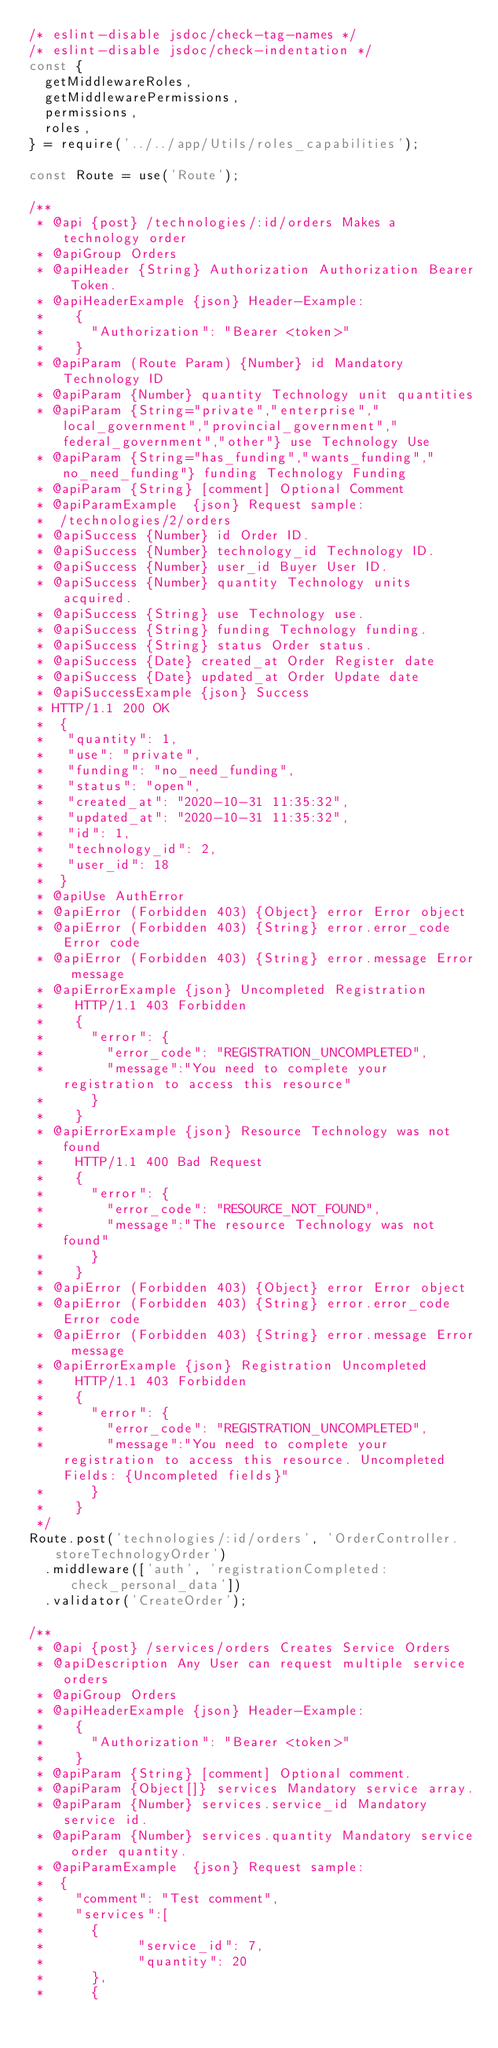Convert code to text. <code><loc_0><loc_0><loc_500><loc_500><_JavaScript_>/* eslint-disable jsdoc/check-tag-names */
/* eslint-disable jsdoc/check-indentation */
const {
	getMiddlewareRoles,
	getMiddlewarePermissions,
	permissions,
	roles,
} = require('../../app/Utils/roles_capabilities');

const Route = use('Route');

/**
 * @api {post} /technologies/:id/orders Makes a technology order
 * @apiGroup Orders
 * @apiHeader {String} Authorization Authorization Bearer Token.
 * @apiHeaderExample {json} Header-Example:
 *    {
 *      "Authorization": "Bearer <token>"
 *    }
 * @apiParam (Route Param) {Number} id Mandatory Technology ID
 * @apiParam {Number} quantity Technology unit quantities
 * @apiParam {String="private","enterprise","local_government","provincial_government","federal_government","other"} use Technology Use
 * @apiParam {String="has_funding","wants_funding","no_need_funding"} funding Technology Funding
 * @apiParam {String} [comment] Optional Comment
 * @apiParamExample  {json} Request sample:
 *	/technologies/2/orders
 * @apiSuccess {Number} id Order ID.
 * @apiSuccess {Number} technology_id Technology ID.
 * @apiSuccess {Number} user_id Buyer User ID.
 * @apiSuccess {Number} quantity Technology units acquired.
 * @apiSuccess {String} use Technology use.
 * @apiSuccess {String} funding Technology funding.
 * @apiSuccess {String} status Order status.
 * @apiSuccess {Date} created_at Order Register date
 * @apiSuccess {Date} updated_at Order Update date
 * @apiSuccessExample {json} Success
 * HTTP/1.1 200 OK
 *	{
 *	 "quantity": 1,
 *	 "use": "private",
 *	 "funding": "no_need_funding",
 *	 "status": "open",
 *	 "created_at": "2020-10-31 11:35:32",
 *	 "updated_at": "2020-10-31 11:35:32",
 *	 "id": 1,
 *	 "technology_id": 2,
 *	 "user_id": 18
 *	}
 * @apiUse AuthError
 * @apiError (Forbidden 403) {Object} error Error object
 * @apiError (Forbidden 403) {String} error.error_code Error code
 * @apiError (Forbidden 403) {String} error.message Error message
 * @apiErrorExample {json} Uncompleted Registration
 *    HTTP/1.1 403 Forbidden
 *		{
 * 			"error": {
 *   			"error_code": "REGISTRATION_UNCOMPLETED",
 *   			"message":"You need to complete your registration to access this resource"
 * 			}
 *		}
 * @apiErrorExample {json} Resource Technology was not found
 *    HTTP/1.1 400 Bad Request
 *		{
 * 			"error": {
 *   			"error_code": "RESOURCE_NOT_FOUND",
 *   			"message":"The resource Technology was not found"
 * 			}
 *		}
 * @apiError (Forbidden 403) {Object} error Error object
 * @apiError (Forbidden 403) {String} error.error_code Error code
 * @apiError (Forbidden 403) {String} error.message Error message
 * @apiErrorExample {json} Registration Uncompleted
 *    HTTP/1.1 403 Forbidden
 *		{
 * 			"error": {
 *   			"error_code": "REGISTRATION_UNCOMPLETED",
 *   			"message":"You need to complete your registration to access this resource. Uncompleted Fields: {Uncompleted fields}"
 * 			}
 *		}
 */
Route.post('technologies/:id/orders', 'OrderController.storeTechnologyOrder')
	.middleware(['auth', 'registrationCompleted:check_personal_data'])
	.validator('CreateOrder');

/**
 * @api {post} /services/orders Creates Service Orders
 * @apiDescription Any User can request multiple service orders
 * @apiGroup Orders
 * @apiHeaderExample {json} Header-Example:
 *    {
 *      "Authorization": "Bearer <token>"
 *    }
 * @apiParam {String} [comment] Optional comment.
 * @apiParam {Object[]} services Mandatory service array.
 * @apiParam {Number} services.service_id Mandatory service id.
 * @apiParam {Number} services.quantity Mandatory service order quantity.
 * @apiParamExample  {json} Request sample:
 *	{
 *	 	"comment": "Test comment",
 *		"services":[
 *			{
 *						"service_id": 7,
 *						"quantity": 20
 *			},
 *			{</code> 